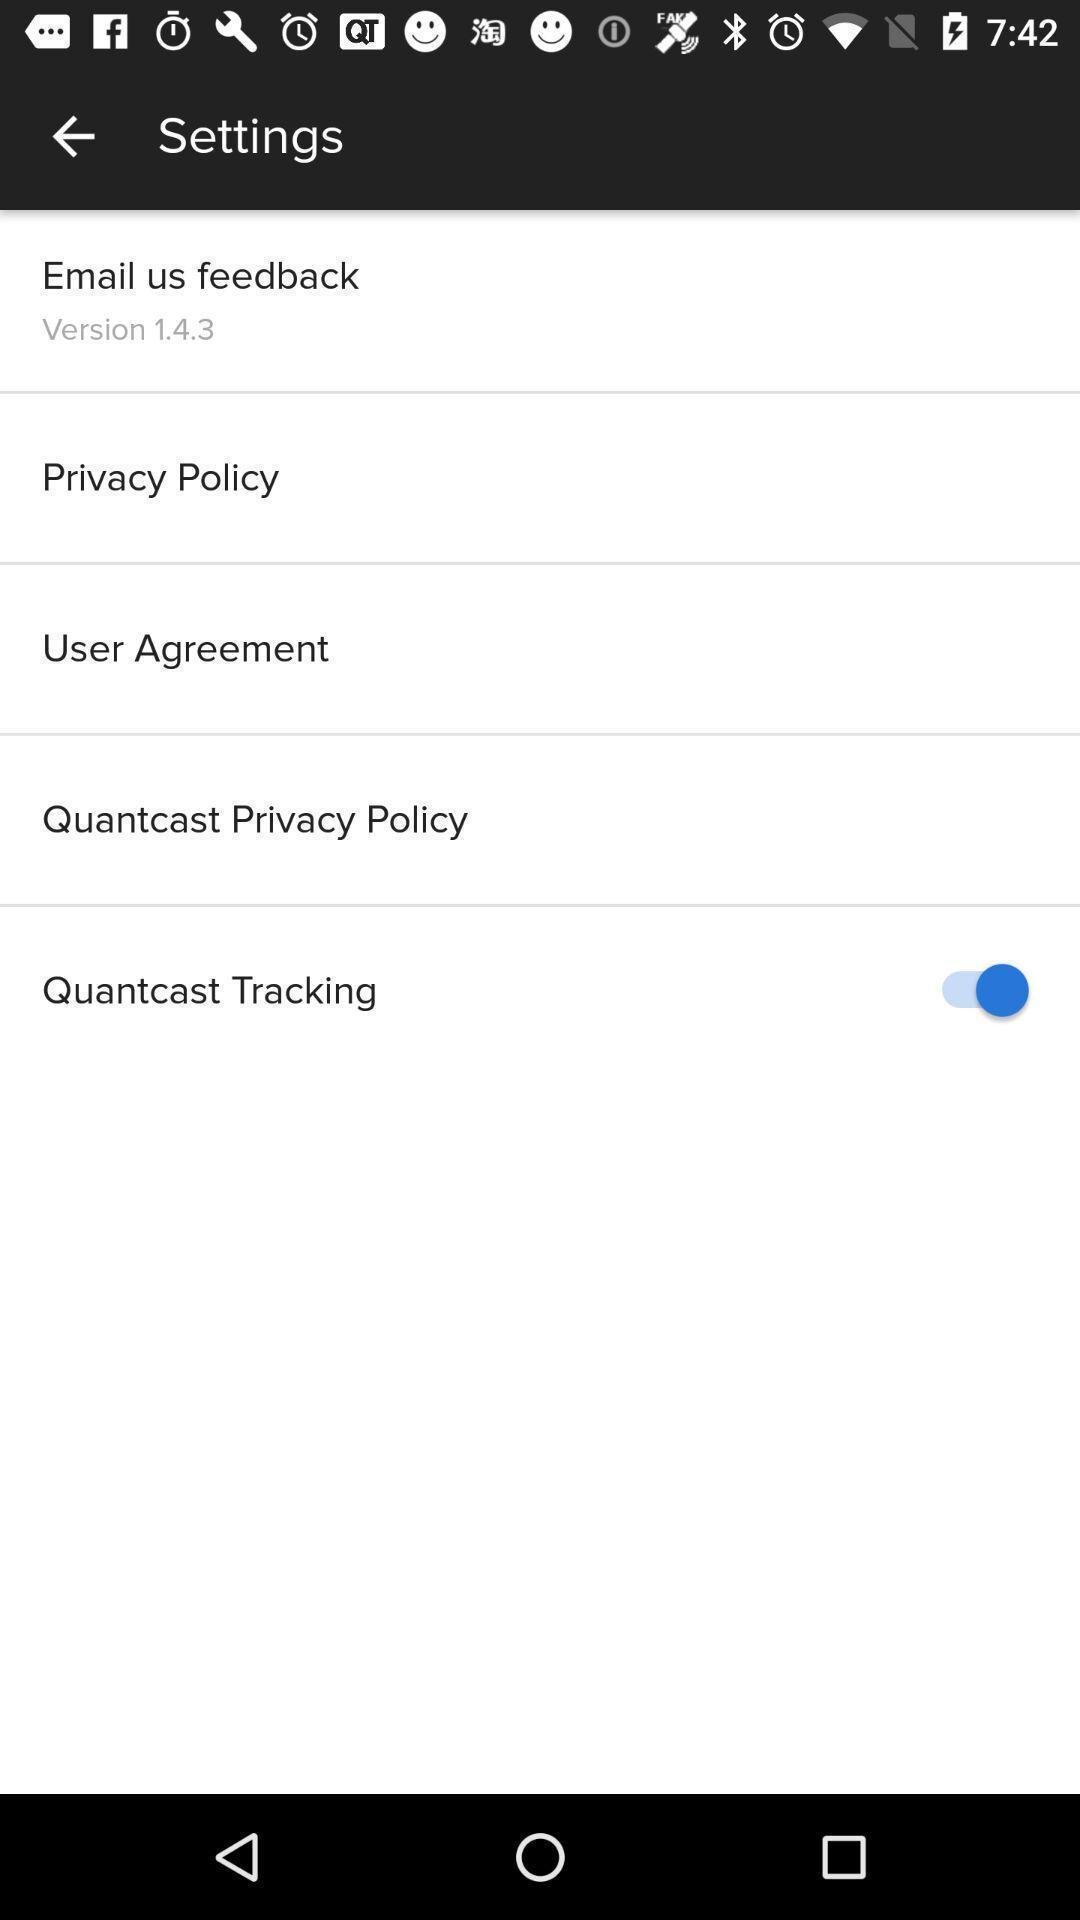Describe this image in words. Screen showing settings page. 